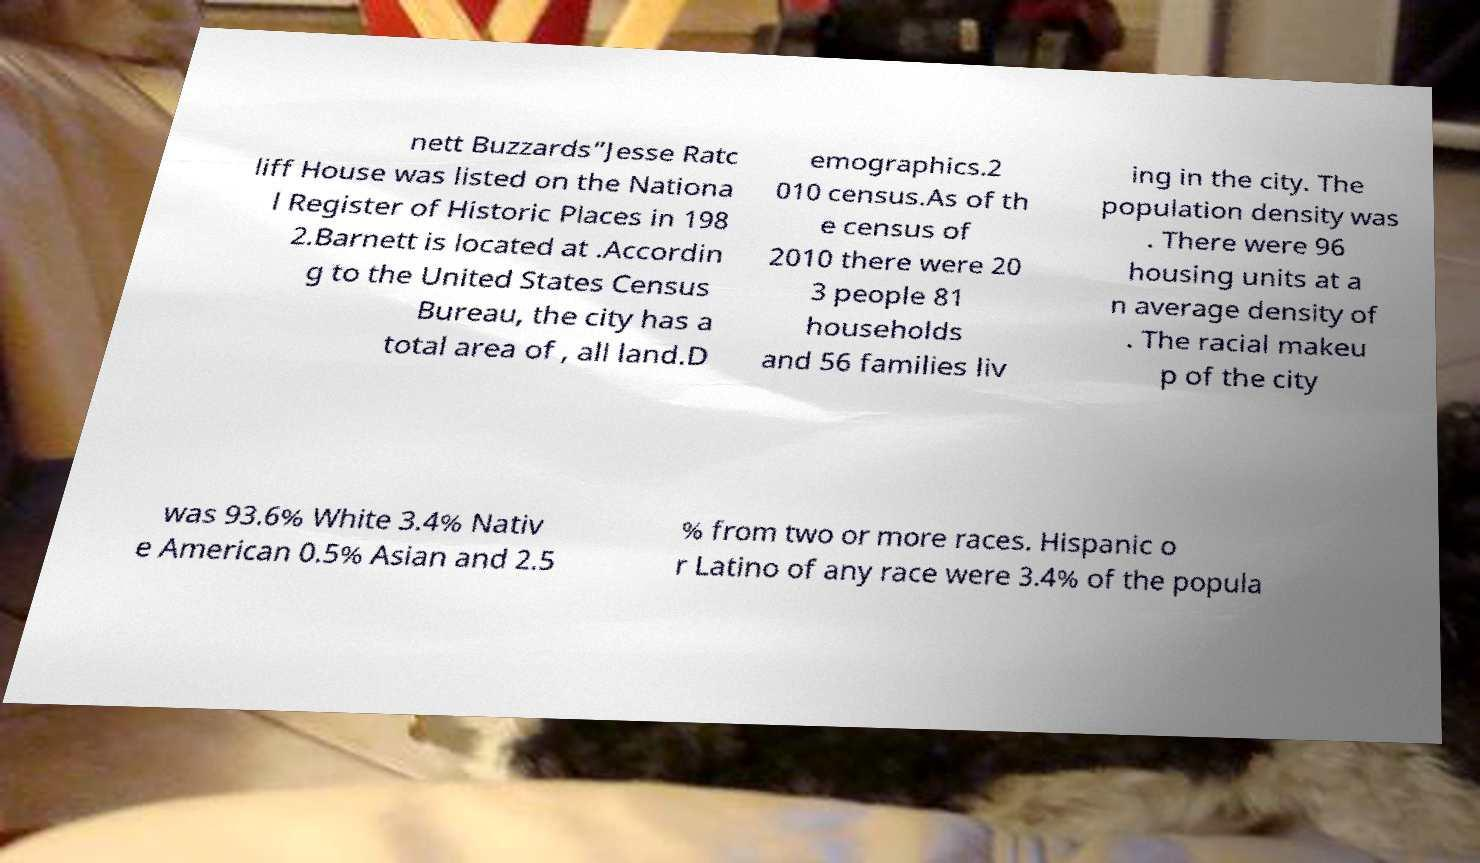What messages or text are displayed in this image? I need them in a readable, typed format. nett Buzzards”Jesse Ratc liff House was listed on the Nationa l Register of Historic Places in 198 2.Barnett is located at .Accordin g to the United States Census Bureau, the city has a total area of , all land.D emographics.2 010 census.As of th e census of 2010 there were 20 3 people 81 households and 56 families liv ing in the city. The population density was . There were 96 housing units at a n average density of . The racial makeu p of the city was 93.6% White 3.4% Nativ e American 0.5% Asian and 2.5 % from two or more races. Hispanic o r Latino of any race were 3.4% of the popula 